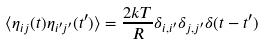<formula> <loc_0><loc_0><loc_500><loc_500>\langle \eta _ { i j } ( t ) \eta _ { i ^ { \prime } j ^ { \prime } } ( t ^ { \prime } ) \rangle = \frac { 2 k T } { R } \delta _ { i , i ^ { \prime } } \delta _ { j , j ^ { \prime } } \delta ( t - t ^ { \prime } )</formula> 